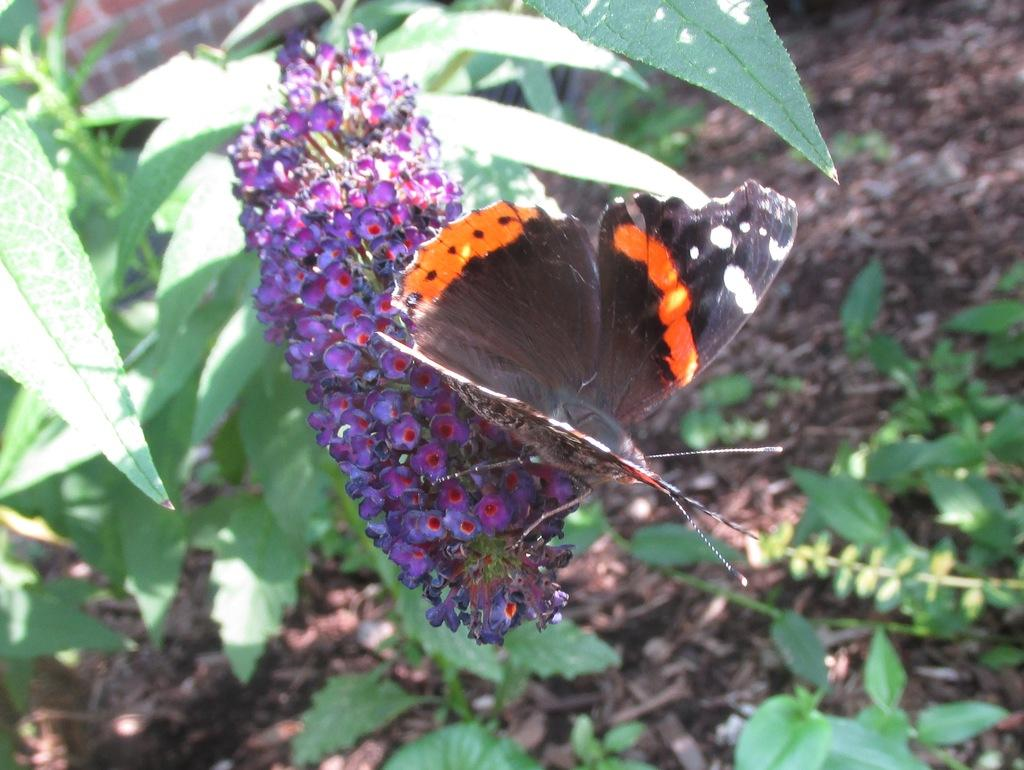What type of plants can be seen in the image? There are flowers in the image. Is there any other living organism interacting with the flowers? Yes, there is a butterfly on the flowers. What can be seen in the background of the image? There are leaves in the background of the image. What advice does the father give to the crush in the image? There is no father or crush present in the image; it features flowers and a butterfly. What type of fruit is visible in the image? There is no fruit, such as a banana, present in the image. 